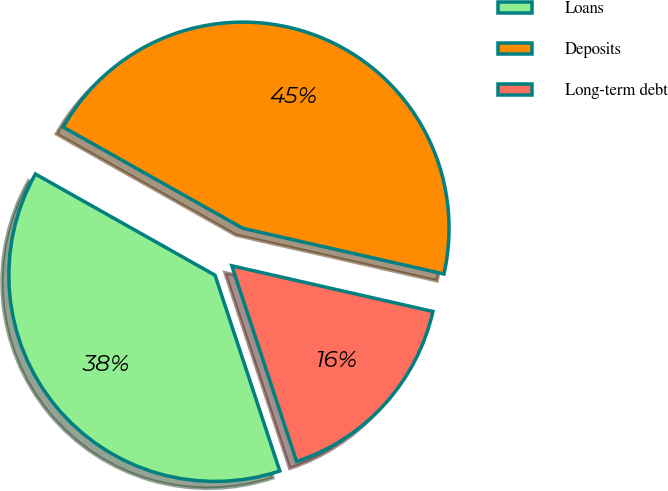<chart> <loc_0><loc_0><loc_500><loc_500><pie_chart><fcel>Loans<fcel>Deposits<fcel>Long-term debt<nl><fcel>38.25%<fcel>45.39%<fcel>16.36%<nl></chart> 